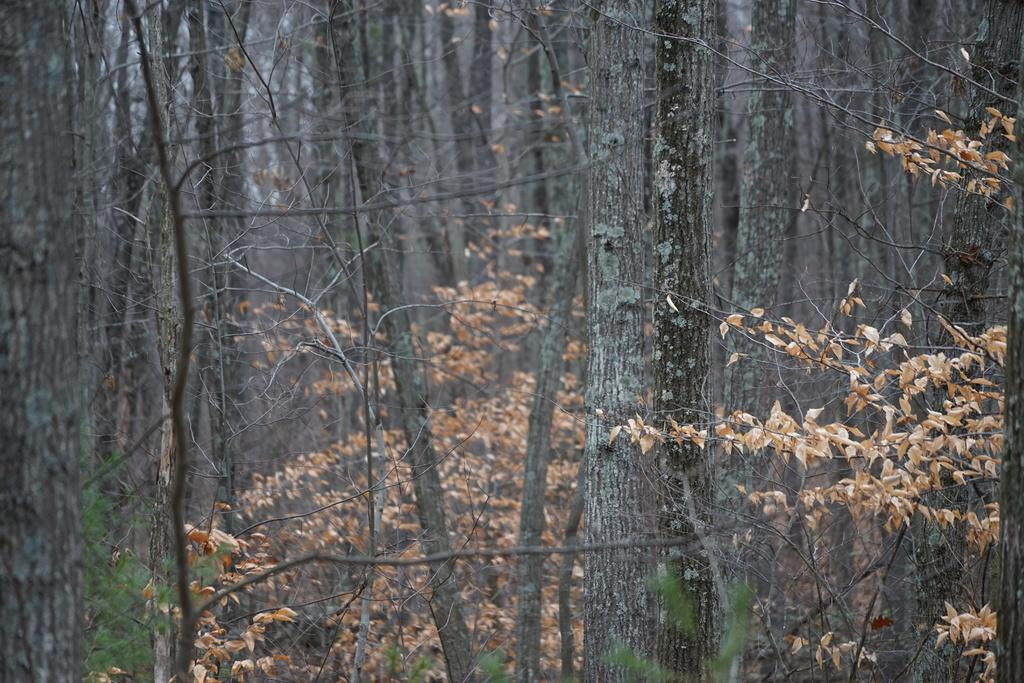What type of vegetation can be seen in the image? There are tree trunks and grass in the image. What part of the natural environment is visible in the image? The sky is visible in the image. Can you describe the setting where the image might have been taken? The image may have been taken in a forest, given the presence of tree trunks. What type of cart is being pushed by the actor in the image? There is no actor or cart present in the image. What detail can be seen on the tree trunks in the image? The facts provided do not mention any specific details on the tree trunks, so we cannot answer this question definitively. 